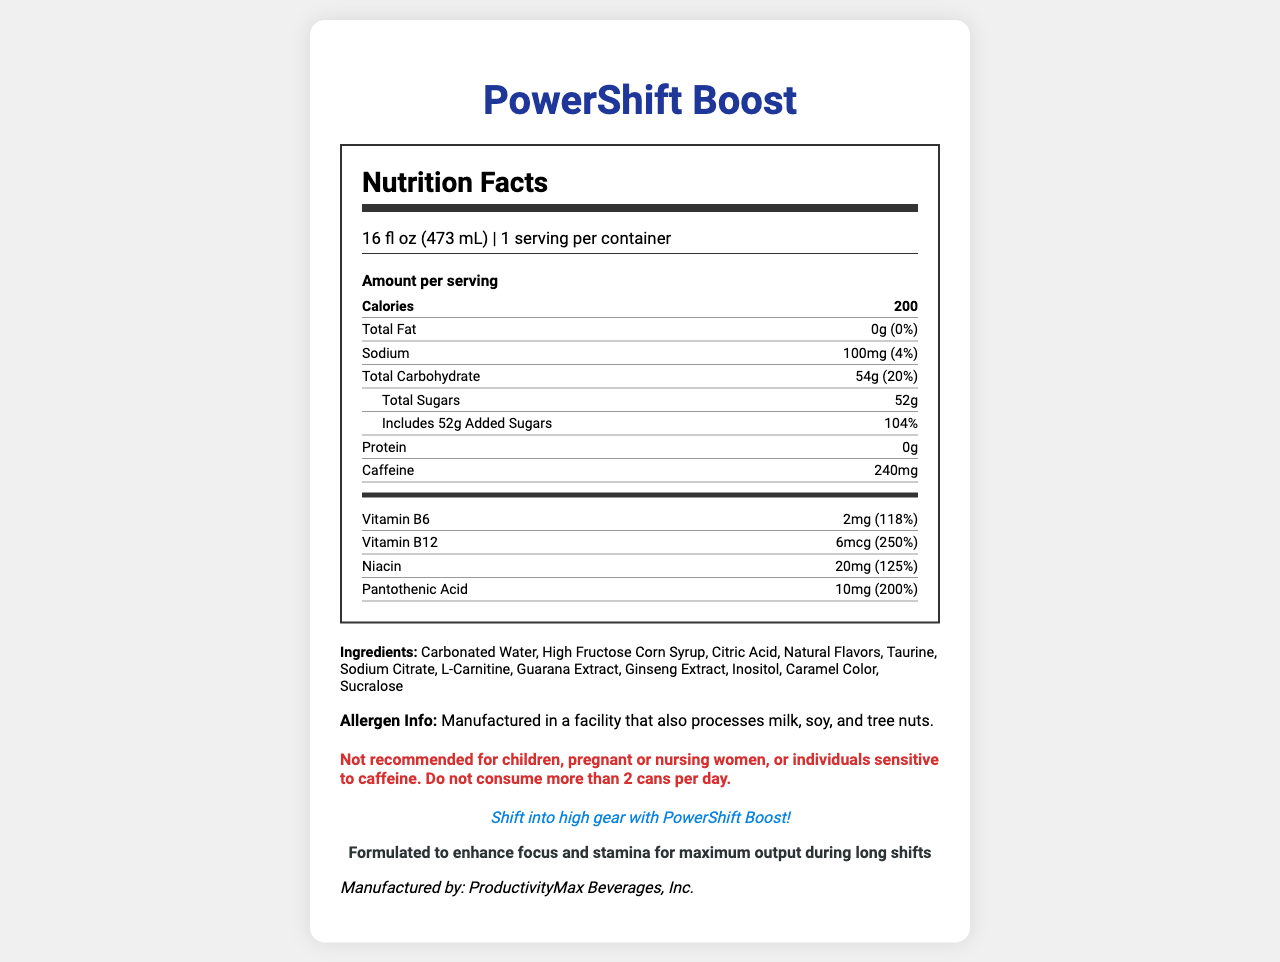what is the serving size of PowerShift Boost? The serving size is listed as "16 fl oz (473 mL)" near the top of the nutrition facts section.
Answer: 16 fl oz (473 mL) How many servings per container are there? It is mentioned directly under the serving size: "1 serving per container."
Answer: 1 what is the total carbohydrate content per serving? The total carbohydrate content is shown as "54g" in the nutrient section of the label.
Answer: 54g How much caffeine does PowerShift Boost contain per serving? The amount of caffeine is specified as "240mg" in the nutrient section.
Answer: 240mg Which vitamin has the highest daily value percentage? A. Vitamin B6 B. Vitamin B12 C. Niacin D. Pantothenic Acid Vitamin B12 has the highest daily value at 250%, as mentioned in the vitamins section.
Answer: B. Vitamin B12 What percentage of the daily value for sodium does one serving provide? The daily value percentage for sodium is listed as "4%" in the nutrient section.
Answer: 4% Is there any protein in a serving of PowerShift Boost? The nutrient section shows "Protein: 0g," indicating that there is no protein.
Answer: No What is the amount of added sugars in one serving? The amount of added sugars is specified as "52g" right beneath the total sugars listing.
Answer: 52g Which of the following is an ingredient in PowerShift Boost? A. Citric Acid B. Aspartame C. Stevia D. Maltodextrin Citric Acid is listed as one of the ingredients under the ingredients section.
Answer: A. Citric Acid can PowerShift Boost be consumed by children? The warning section explicitly states, "Not recommended for children."
Answer: No What is the slogan for PowerShift Boost? The slogan is clearly stated as "Shift into high gear with PowerShift Boost!" near the end of the document.
Answer: Shift into high gear with PowerShift Boost! Who is the manufacturer of PowerShift Boost? The manufacturer is listed at the bottom of the document as "Manufactured by: ProductivityMax Beverages, Inc."
Answer: ProductivityMax Beverages, Inc. What is the total calorie content per serving? The calorie content is listed as "200" in the nutrient section.
Answer: 200 Summarize the main aim of the PowerShift Boost energy drink. The goal of the drink is highlighted in the statement: "Formulated to enhance focus and stamina for maximum output during long shifts."
Answer: The main aim of PowerShift Boost is to enhance focus and stamina for maximum output during long shifts, targeting individuals needing a productivity and alertness boost. Is PowerShift Boost recommended for pregnant women? The warning section states, "Not recommended for... pregnant or nursing women."
Answer: No How many calories come from fat? The document only provides the total calories and total fat amount but does not specify how many of the calories come from fat.
Answer: Cannot be determined 